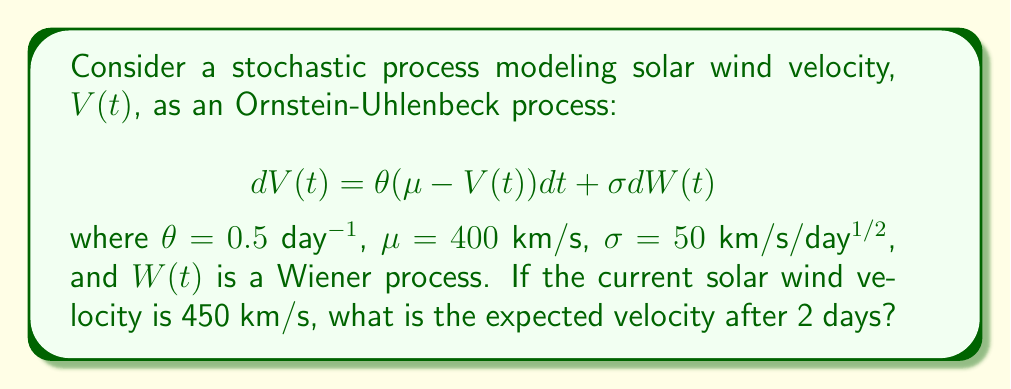Solve this math problem. To solve this problem, we'll follow these steps:

1) The Ornstein-Uhlenbeck process has a known mean and variance for its future values. For a process starting at $V(0) = v_0$, the expected value at time $t$ is given by:

   $$E[V(t)|V(0)=v_0] = \mu + (v_0 - \mu)e^{-\theta t}$$

2) In our case:
   - $v_0 = 450$ km/s (current velocity)
   - $\mu = 400$ km/s (long-term mean)
   - $\theta = 0.5$ day$^{-1}$
   - $t = 2$ days

3) Let's substitute these values into the formula:

   $$E[V(2)|V(0)=450] = 400 + (450 - 400)e^{-0.5 \cdot 2}$$

4) Simplify:
   $$E[V(2)|V(0)=450] = 400 + 50e^{-1}$$

5) Calculate:
   $$E[V(2)|V(0)=450] = 400 + 50 \cdot 0.3679 \approx 418.395$$

Therefore, the expected solar wind velocity after 2 days is approximately 418.395 km/s.
Answer: 418.395 km/s 